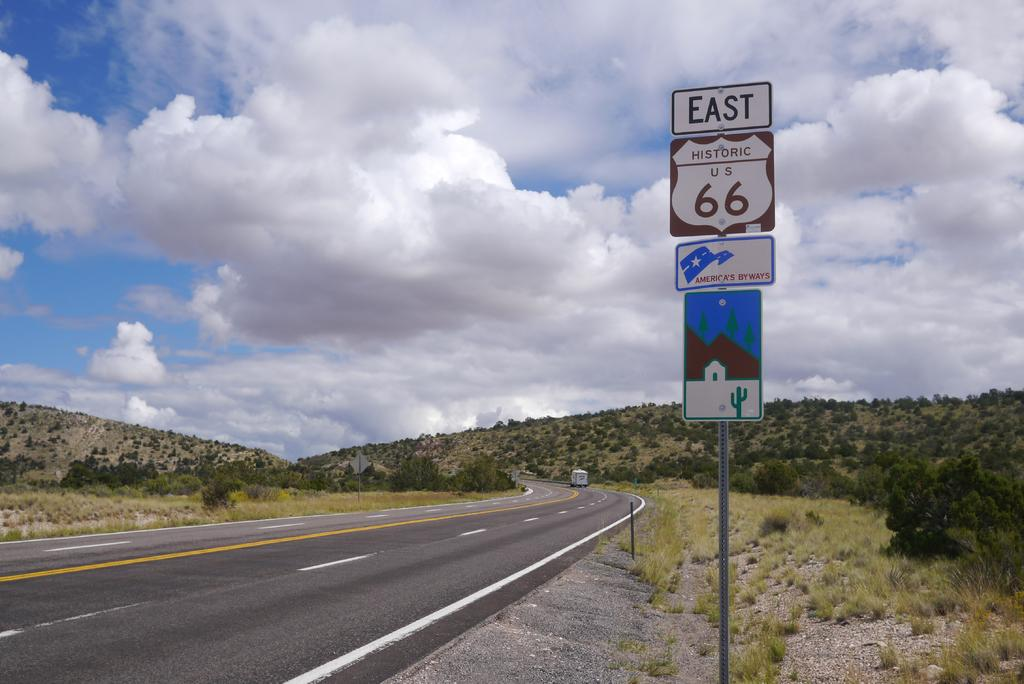<image>
Provide a brief description of the given image. A black and white street sign that says east 66 on it. 